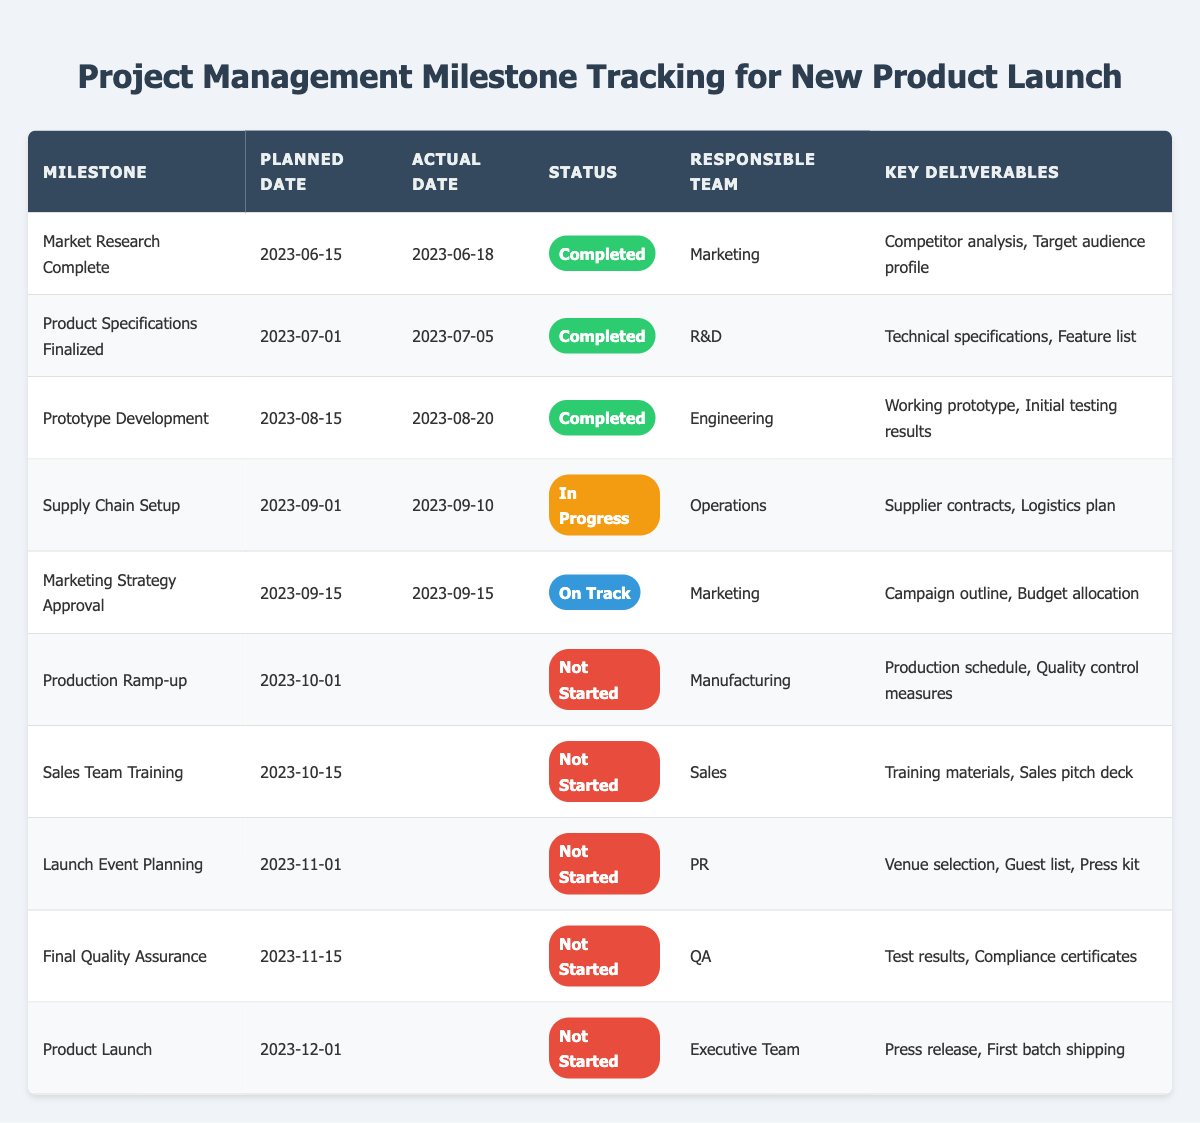What is the status of the "Prototype Development" milestone? The "Prototype Development" milestone has a status listed as "Completed" in the table.
Answer: Completed How many milestones are marked as "Not Started"? By reviewing the Status column, we can count the number of entries that say "Not Started," specifically for Production Ramp-up, Sales Team Training, Launch Event Planning, Final Quality Assurance, and Product Launch. This totals 5 milestones.
Answer: 5 Which team is responsible for the "Marketing Strategy Approval"? The Responsible Team column indicates that the Marketing team is responsible for the "Marketing Strategy Approval" milestone.
Answer: Marketing What were the key deliverables for the "Supply Chain Setup" milestone? Looking at the Key Deliverables column adjacent to the "Supply Chain Setup" milestone, it lists "Supplier contracts, Logistics plan" as the deliverables.
Answer: Supplier contracts, Logistics plan Is the "Final Quality Assurance" milestone ahead of its planned date? The table shows that "Final Quality Assurance" is scheduled for 2023-11-15 and has not started, indicating that it is on track and still before its planned date, so the statement is true.
Answer: Yes Which milestone has the latest planned date, and what is its status? Scanning the Planned Date column, the milestone with the latest date is "Product Launch" on 2023-12-01, which is marked as "Not Started."
Answer: Product Launch, Not Started What is the average planned date for completed milestones? To find the average, we first look at the planned dates of completed milestones: 2023-06-15, 2023-07-01, and 2023-08-15. Converting these dates into days: 15, 1, and 15 gives us (15 + 1 + 15) / 3 = 10.33 (approximately the 10th day of the month). In terms of month, it is July 2023, and the average planned date is closest to mid-July.
Answer: July 2023 Which organizational teams do not have any completed milestones? Examining the Responsible Team column alongside the Status column shows that the Manufacturing, Sales, PR, QA, and Executive Team have no completed milestones as they are either not started or in progress.
Answer: Manufacturing, Sales, PR, QA, Executive Team Was the "Market Research Complete" milestone behind schedule? The Actual Date for "Market Research Complete" is 2023-06-18, and the Planned Date was 2023-06-15. Since the actual date is later than the planned date, this means it was behind schedule.
Answer: Yes 